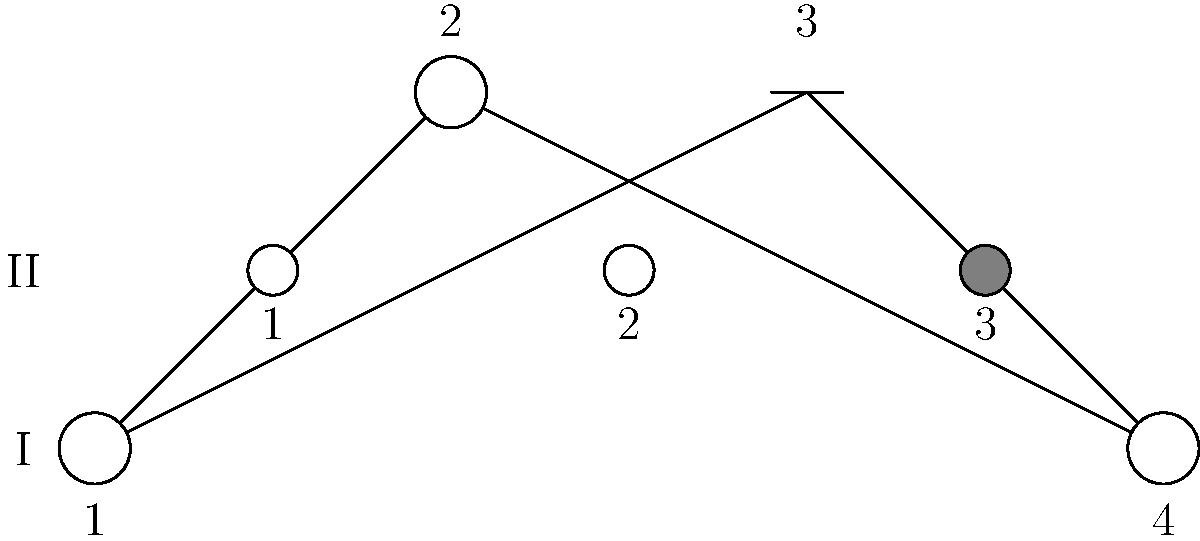Based on the family pedigree chart shown, which represents an autosomal dominant inheritance pattern, what is the probability that the next child of individuals II-2 and II-3 will be affected by the genetic condition? To determine the probability of the next child being affected, we need to follow these steps:

1. Identify the inheritance pattern: The pedigree shows an autosomal dominant inheritance pattern because:
   - The condition appears in every generation
   - Affected individuals can pass the trait to both males and females
   - Unaffected individuals do not pass the trait to their offspring

2. Analyze the parents' genotypes:
   - II-2 is unaffected, so their genotype must be homozygous recessive (nn)
   - II-3 is affected, so their genotype must be heterozygous (Nn) because:
     a) They have an affected parent (I-3)
     b) They have unaffected children (II-1 and II-2)

3. Determine the possible genotype combinations:
   - II-2 (nn) x II-3 (Nn)
   - Possible gametes: (n) from II-2, (N) or (n) from II-3

4. Calculate the probability:
   - Chance of receiving 'N' allele from II-3: 1/2
   - Chance of receiving 'n' allele from II-2: 1 (always)

Therefore, the probability of the next child being affected (Nn) is 1/2 or 50%.
Answer: 50% 